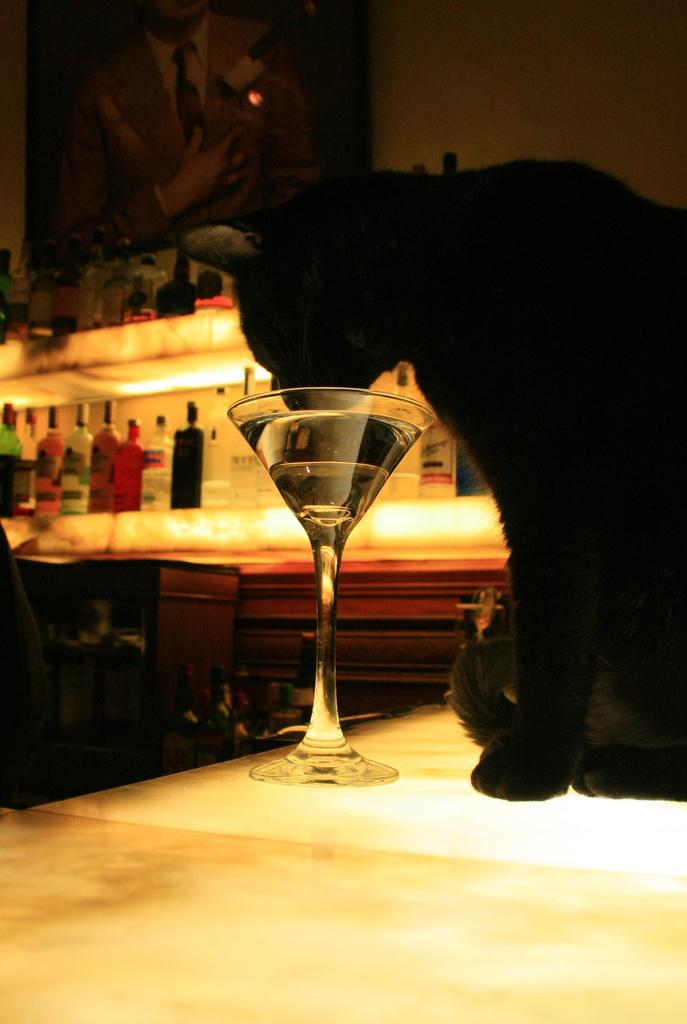What is on the table in the image? There is a glass with a drink on a table in the image. What is the cat doing in the image? The cat is drinking from the glass in the image. What can be seen on the shelf in the image? There is an alcohol bottle on the shelf in the image. What is hanging on the wall in the image? There is a painting hanging on the wall in the image. What type of tiger can be seen in the painting on the wall? There is no tiger present in the image, and therefore no such animal can be observed in the painting. Is the room in the image hot or cold? The provided facts do not give any information about the temperature of the room, so it cannot be determined from the image. 